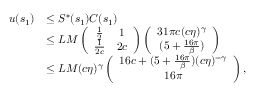<formula> <loc_0><loc_0><loc_500><loc_500>\begin{array} { r l } { u ( s _ { 1 } ) } & { \leq S ^ { \ast } ( s _ { 1 } ) C ( s _ { 1 } ) } \\ & { \leq L M \left ( \begin{array} { c c } { \frac { 1 } { 2 } } & { 1 } \\ { \frac { 1 } 2 c } } & { 2 c } \end{array} \right ) \left ( \begin{array} { c c } { 3 1 \pi c ( c \eta ) ^ { \gamma } } \\ { ( 5 + \frac { 1 6 \pi } \beta ) } \end{array} \right ) } \\ & { \leq L M ( c \eta ) ^ { \gamma } \left ( \begin{array} { c } { 1 6 c + ( 5 + \frac { 1 6 \pi } \beta ) ( c \eta ) ^ { - \gamma } } \\ { 1 6 \pi } \end{array} \right ) , } \end{array}</formula> 